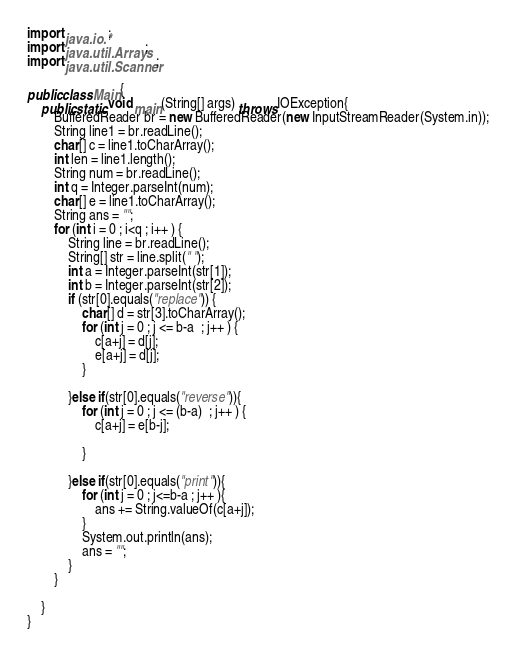Convert code to text. <code><loc_0><loc_0><loc_500><loc_500><_Java_>import java.io.*;
import java.util.Arrays;
import java.util.Scanner;

public class Main{
	public static void main(String[] args) throws IOException{ 
		BufferedReader br = new BufferedReader(new InputStreamReader(System.in));
		String line1 = br.readLine();
		char[] c = line1.toCharArray();
		int len = line1.length();
		String num = br.readLine();
		int q = Integer.parseInt(num);
		char[] e = line1.toCharArray();
		String ans = "";
		for (int i = 0 ; i<q ; i++ ) {
			String line = br.readLine();
			String[] str = line.split(" ");
			int a = Integer.parseInt(str[1]);
			int b = Integer.parseInt(str[2]);
			if (str[0].equals("replace")) {
				char[] d = str[3].toCharArray();
				for (int j = 0 ; j <= b-a  ; j++ ) {
					c[a+j] = d[j];
					e[a+j] = d[j];
				}

			}else if(str[0].equals("reverse")){
				for (int j = 0 ; j <= (b-a)  ; j++ ) {
					c[a+j] = e[b-j];

				}

			}else if(str[0].equals("print")){
				for (int j = 0 ; j<=b-a ; j++ ){
					ans += String.valueOf(c[a+j]);
				} 
				System.out.println(ans);
				ans = "";
			}
		}

	}
}</code> 